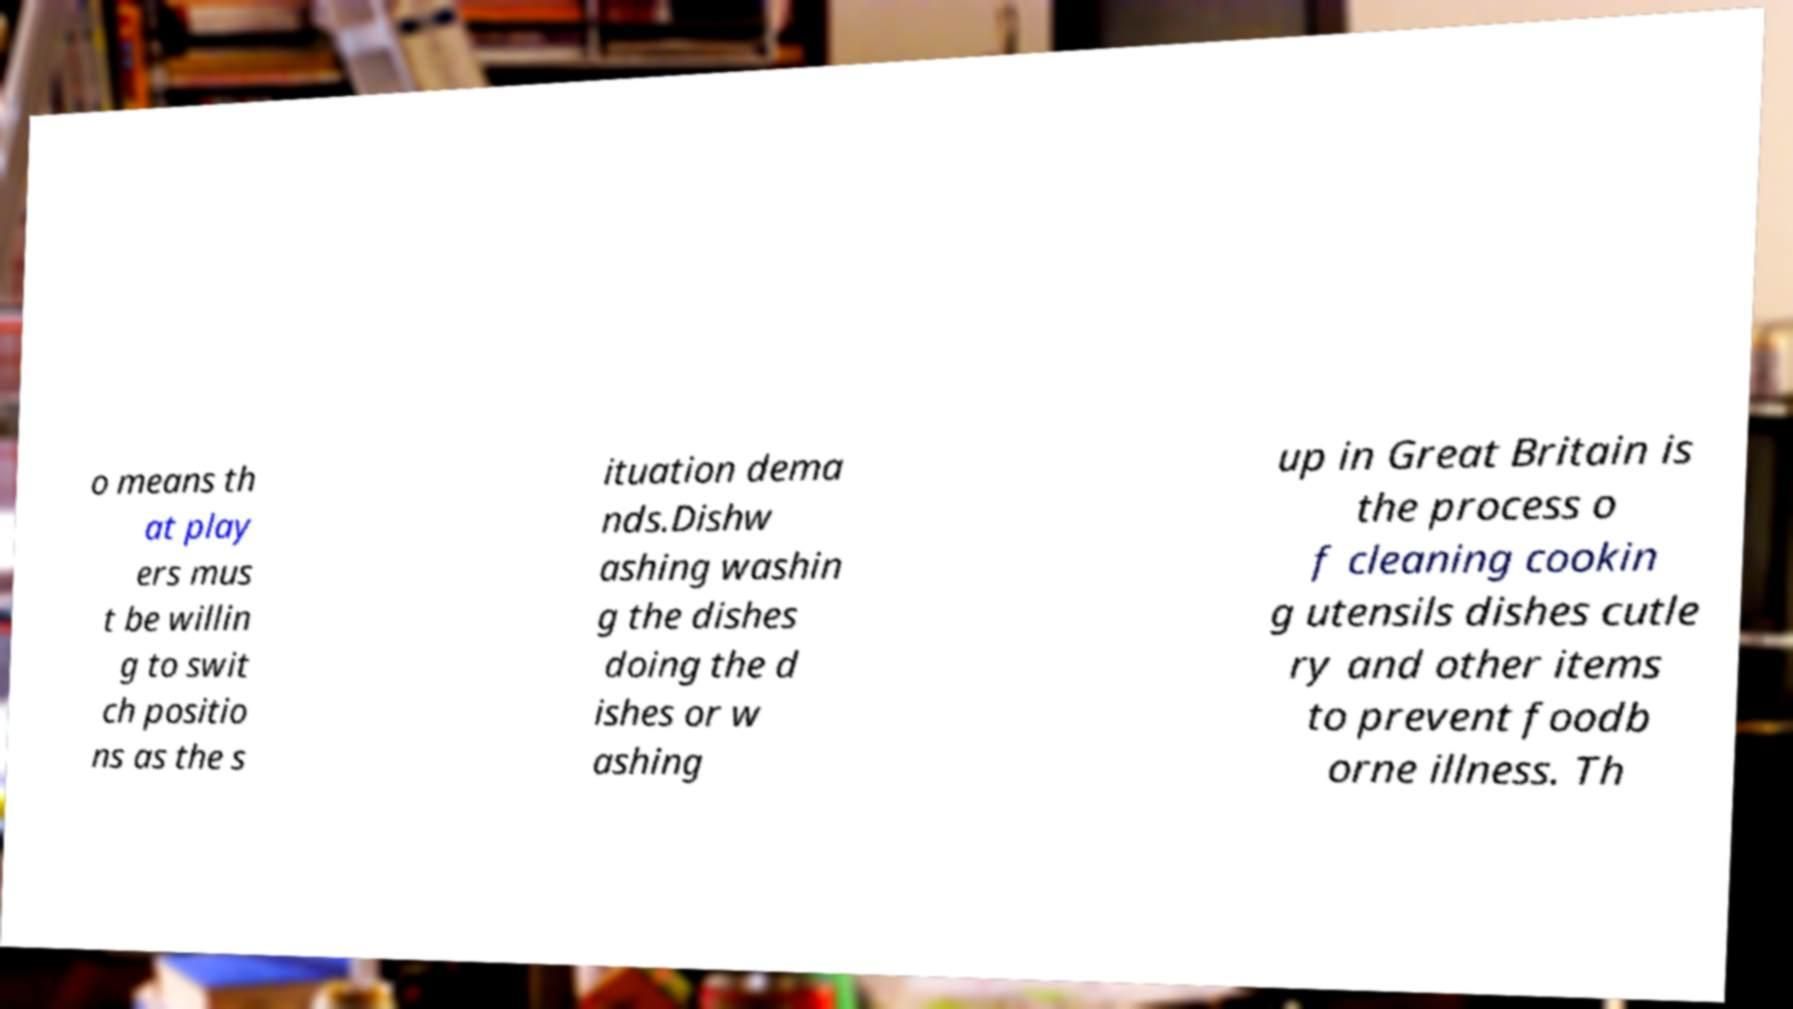For documentation purposes, I need the text within this image transcribed. Could you provide that? o means th at play ers mus t be willin g to swit ch positio ns as the s ituation dema nds.Dishw ashing washin g the dishes doing the d ishes or w ashing up in Great Britain is the process o f cleaning cookin g utensils dishes cutle ry and other items to prevent foodb orne illness. Th 